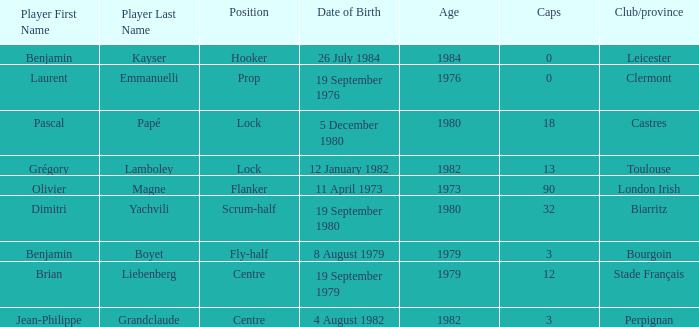What date is the birthday for the 32nd caps? 19 September 1980. 